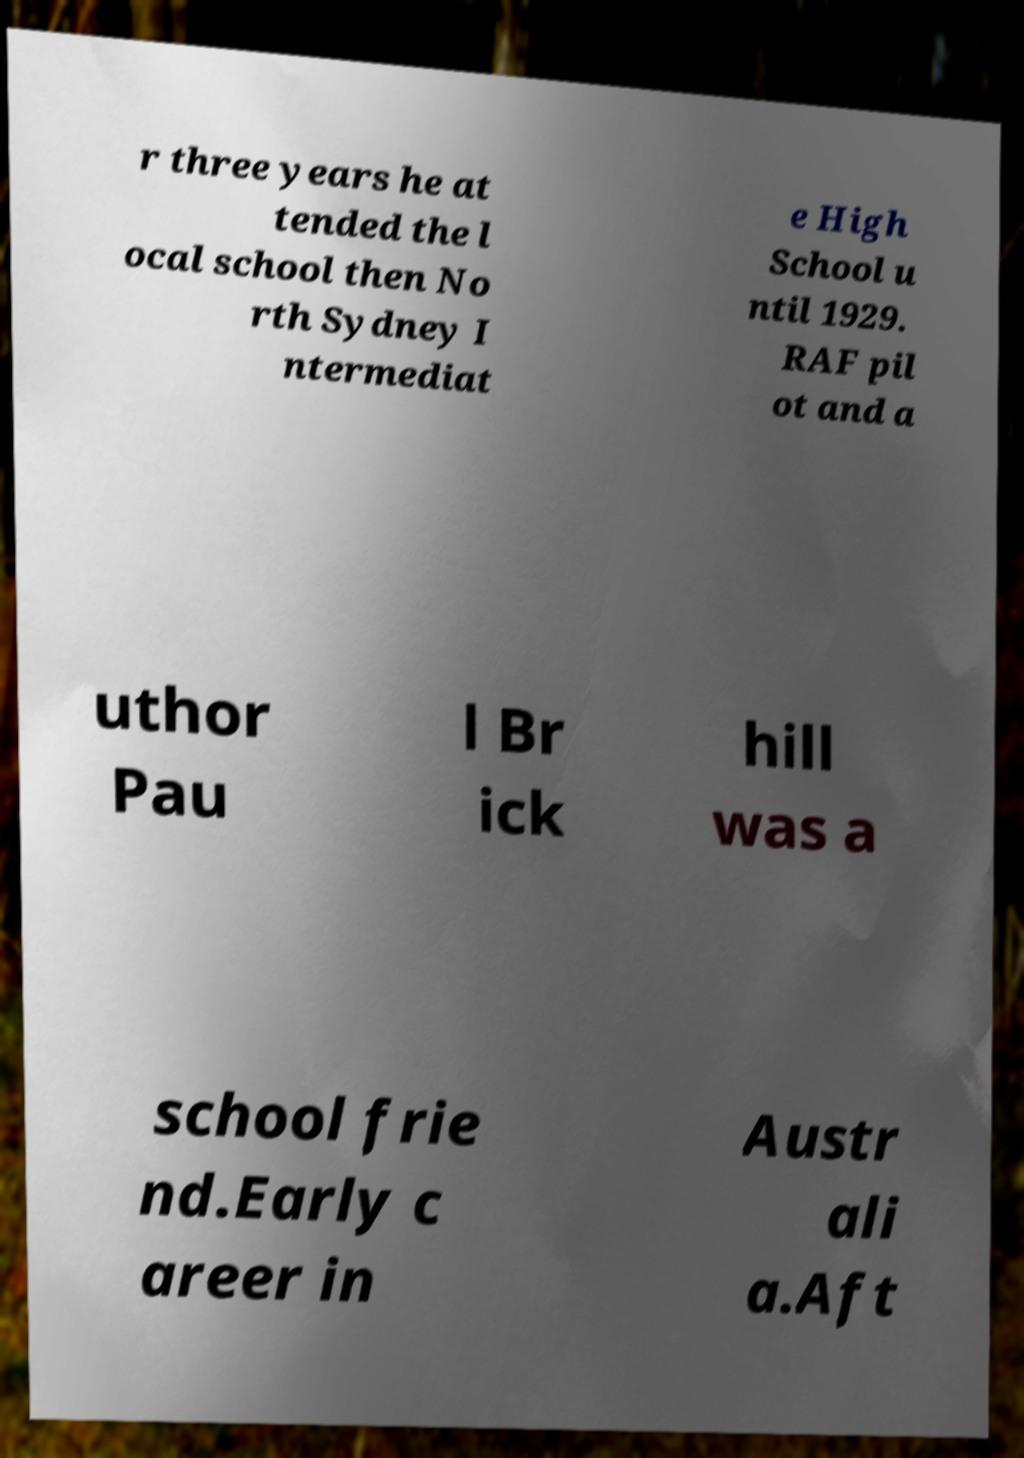There's text embedded in this image that I need extracted. Can you transcribe it verbatim? r three years he at tended the l ocal school then No rth Sydney I ntermediat e High School u ntil 1929. RAF pil ot and a uthor Pau l Br ick hill was a school frie nd.Early c areer in Austr ali a.Aft 